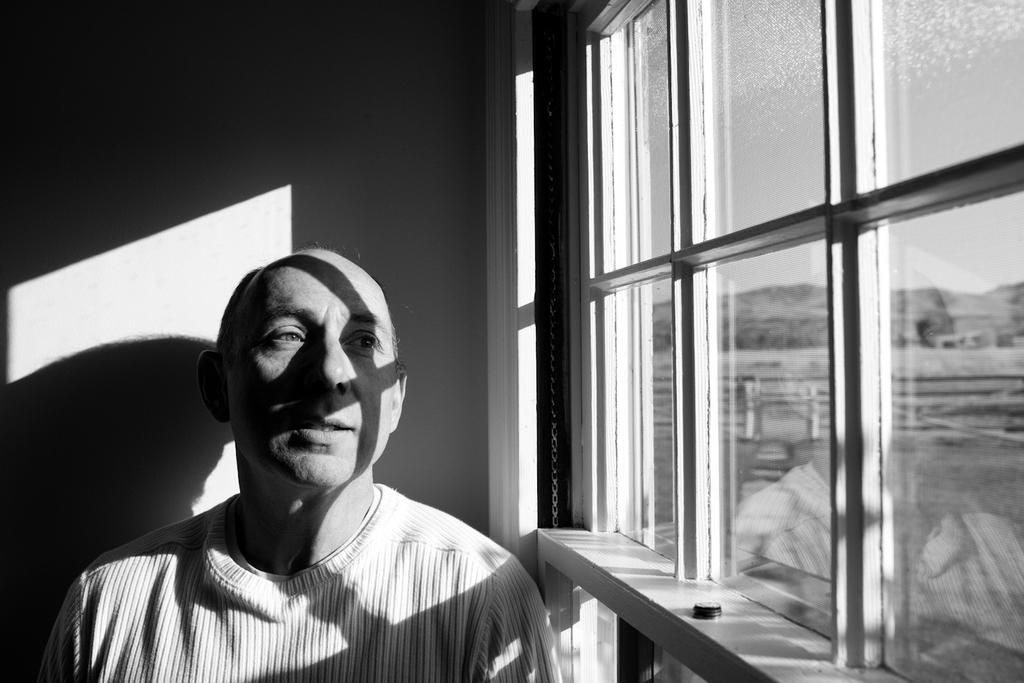What is the color scheme of the image? The image is black and white. Who is present in the image? There is a man in the image. What is the man wearing? The man is wearing clothes. What can be seen through the glass window in the image? A hill and the sky are visible through the window. What type of net is being used by the man in the image? There is no net present in the image; the man is simply standing and wearing clothes. What substance is the man talking about in the image? There is no indication in the image that the man is talking about any substance, as there is no dialogue or context provided. 